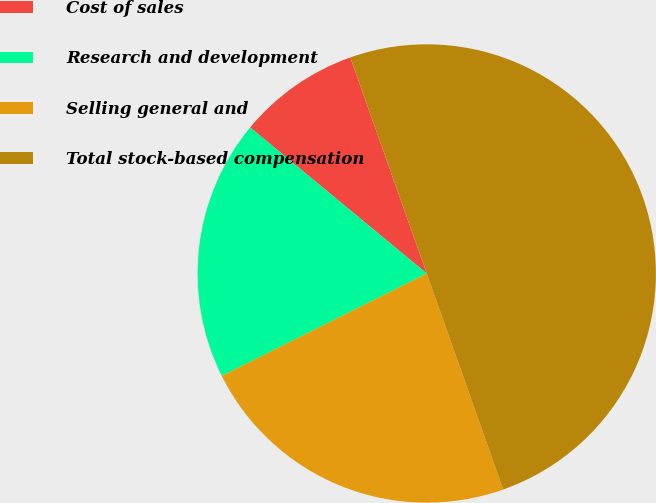<chart> <loc_0><loc_0><loc_500><loc_500><pie_chart><fcel>Cost of sales<fcel>Research and development<fcel>Selling general and<fcel>Total stock-based compensation<nl><fcel>8.59%<fcel>18.37%<fcel>23.04%<fcel>50.0%<nl></chart> 